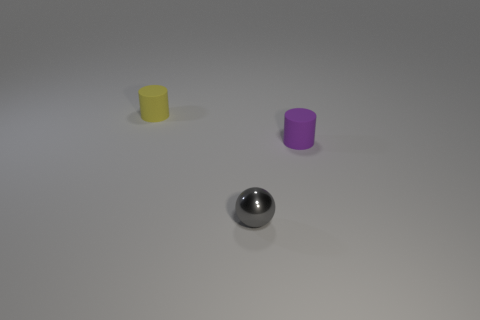Subtract all purple cylinders. How many cylinders are left? 1 Add 2 purple rubber things. How many objects exist? 5 Subtract all balls. How many objects are left? 2 Add 2 cylinders. How many cylinders are left? 4 Add 1 yellow matte things. How many yellow matte things exist? 2 Subtract 0 red cylinders. How many objects are left? 3 Subtract 1 cylinders. How many cylinders are left? 1 Subtract all blue spheres. Subtract all red cylinders. How many spheres are left? 1 Subtract all yellow spheres. How many purple cylinders are left? 1 Subtract all purple rubber cylinders. Subtract all tiny rubber cylinders. How many objects are left? 0 